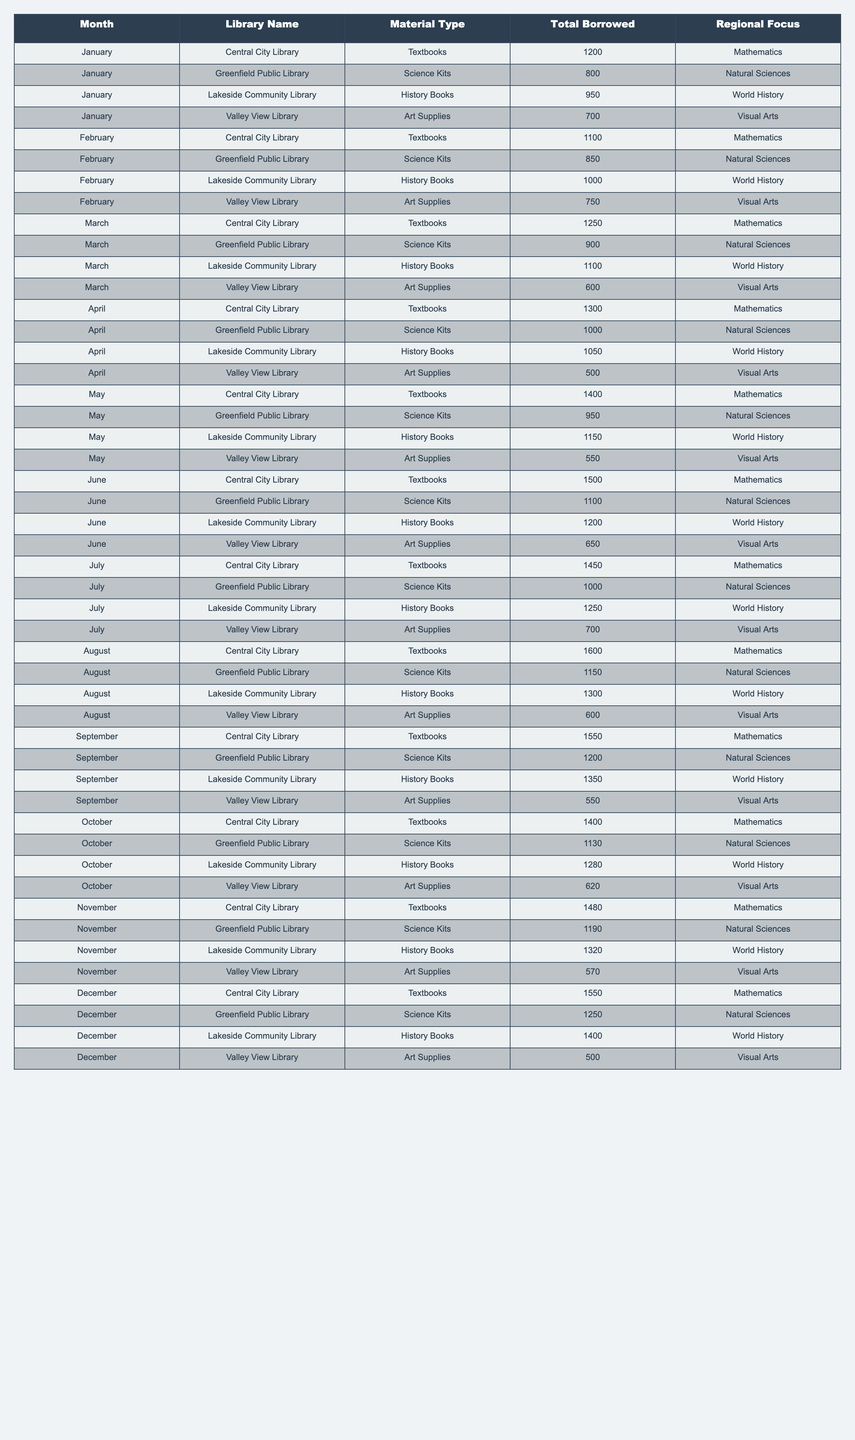What was the highest number of Science Kits borrowed in a single month? By examining the "Total Borrowed" column for the "Science Kits" material type, we can see that the highest value listed is 1250 in December at Greenfield Public Library.
Answer: 1250 Which library borrowed more textbooks in June, Central City Library or Valley View Library? In June, Central City Library borrowed 1500 textbooks while Valley View Library borrowed 650 textbooks. Central City Library borrowed more.
Answer: Central City Library What is the total number of Art Supplies borrowed across all libraries in April? For April, the Art Supplies borrowed were: 500 (Valley View), 750 (Central City), 1050 (Lakeside), totaling up to 500 + 750 + 1050 = 2300.
Answer: 2300 Did the borrowing of History Books increase every month at Lakeside Community Library? Looking at the "Total Borrowed" values for History Books at Lakeside from January (950), February (1000), March (1100), April (1050), May (1150), June (1200), July (1250), August (1300), September (1350), October (1280), November (1320), December (1400), we see a decrease in April and October, therefore it did not increase every month.
Answer: No What is the average number of Textbooks borrowed from the Central City Library over the entire year? We sum the total borrowed each month: 1200 (Jan) + 1100 (Feb) + 1250 (Mar) + 1300 (Apr) + 1400 (May) + 1500 (Jun) + 1450 (Jul) + 1600 (Aug) + 1550 (Sep) + 1400 (Oct) + 1480 (Nov) + 1550 (Dec) =  17400. There are 12 months, so the average is 17400 / 12 = 1450.
Answer: 1450 Which month had the greatest variance in the number of borrowed Science Kits? To calculate variance, we look at the monthly borrowing totals: 800 (Jan), 850 (Feb), 900 (Mar), 1000 (Apr), 950 (May), 1100 (Jun), 1000 (Jul), 1150 (Aug), 1200 (Sep), 1130 (Oct), 1190 (Nov), 1250 (Dec). The month with the highest range is June (lowest previous month was 950 in May) resulting in the greatest variance at 1100 - 800 = 300.
Answer: June Which library consistently had the lowest borrowing of Art Supplies each month? By examining all the months, we can observe that Valley View Library borrowed 700, 750, 600, 550, 500, each time being lower than the other libraries’ values, making it consistently the lowest.
Answer: Valley View Library How many more Science Kits were borrowed in December compared to January? In January, 800 Science Kits were borrowed while 1250 were borrowed in December, resulting in a difference of 1250 - 800 = 450 more in December.
Answer: 450 What was the most frequently borrowed material type across all libraries in August? Observing the data for August 2023: Textbooks (1600), Science Kits (1150), History Books (1300), Art Supplies (600). The most borrowed type was Textbooks at 1600.
Answer: Textbooks 